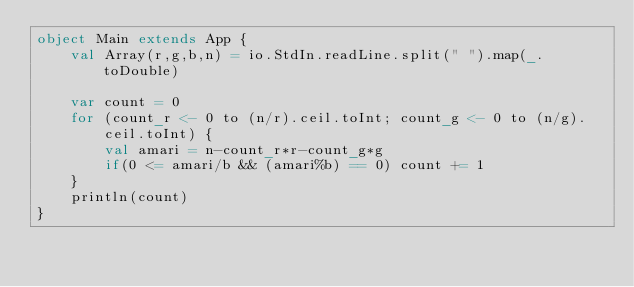<code> <loc_0><loc_0><loc_500><loc_500><_Scala_>object Main extends App {
    val Array(r,g,b,n) = io.StdIn.readLine.split(" ").map(_.toDouble)

    var count = 0
    for (count_r <- 0 to (n/r).ceil.toInt; count_g <- 0 to (n/g).ceil.toInt) {
        val amari = n-count_r*r-count_g*g
        if(0 <= amari/b && (amari%b) == 0) count += 1
    }
    println(count)
}</code> 